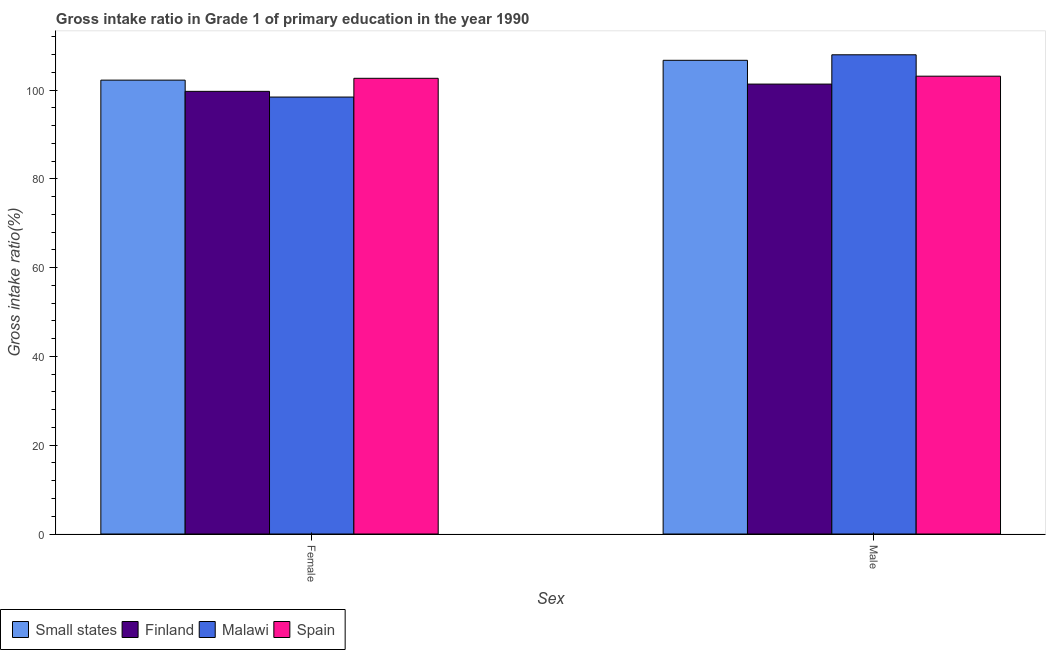What is the label of the 2nd group of bars from the left?
Give a very brief answer. Male. What is the gross intake ratio(male) in Small states?
Provide a succinct answer. 106.71. Across all countries, what is the maximum gross intake ratio(female)?
Provide a succinct answer. 102.65. Across all countries, what is the minimum gross intake ratio(male)?
Give a very brief answer. 101.35. In which country was the gross intake ratio(male) minimum?
Offer a very short reply. Finland. What is the total gross intake ratio(female) in the graph?
Provide a succinct answer. 403.04. What is the difference between the gross intake ratio(female) in Small states and that in Finland?
Your answer should be compact. 2.53. What is the difference between the gross intake ratio(male) in Small states and the gross intake ratio(female) in Spain?
Your answer should be very brief. 4.06. What is the average gross intake ratio(male) per country?
Offer a very short reply. 104.79. What is the difference between the gross intake ratio(male) and gross intake ratio(female) in Finland?
Keep it short and to the point. 1.64. What is the ratio of the gross intake ratio(male) in Small states to that in Malawi?
Give a very brief answer. 0.99. What does the 3rd bar from the left in Male represents?
Offer a terse response. Malawi. What does the 1st bar from the right in Male represents?
Offer a terse response. Spain. How many countries are there in the graph?
Keep it short and to the point. 4. Does the graph contain any zero values?
Ensure brevity in your answer.  No. Does the graph contain grids?
Provide a short and direct response. No. What is the title of the graph?
Ensure brevity in your answer.  Gross intake ratio in Grade 1 of primary education in the year 1990. What is the label or title of the X-axis?
Offer a very short reply. Sex. What is the label or title of the Y-axis?
Offer a terse response. Gross intake ratio(%). What is the Gross intake ratio(%) of Small states in Female?
Provide a short and direct response. 102.24. What is the Gross intake ratio(%) in Finland in Female?
Your response must be concise. 99.71. What is the Gross intake ratio(%) of Malawi in Female?
Ensure brevity in your answer.  98.43. What is the Gross intake ratio(%) of Spain in Female?
Your answer should be very brief. 102.65. What is the Gross intake ratio(%) of Small states in Male?
Give a very brief answer. 106.71. What is the Gross intake ratio(%) in Finland in Male?
Offer a terse response. 101.35. What is the Gross intake ratio(%) of Malawi in Male?
Offer a very short reply. 107.95. What is the Gross intake ratio(%) of Spain in Male?
Your answer should be compact. 103.13. Across all Sex, what is the maximum Gross intake ratio(%) of Small states?
Make the answer very short. 106.71. Across all Sex, what is the maximum Gross intake ratio(%) of Finland?
Offer a very short reply. 101.35. Across all Sex, what is the maximum Gross intake ratio(%) of Malawi?
Ensure brevity in your answer.  107.95. Across all Sex, what is the maximum Gross intake ratio(%) of Spain?
Provide a succinct answer. 103.13. Across all Sex, what is the minimum Gross intake ratio(%) of Small states?
Your answer should be very brief. 102.24. Across all Sex, what is the minimum Gross intake ratio(%) in Finland?
Give a very brief answer. 99.71. Across all Sex, what is the minimum Gross intake ratio(%) of Malawi?
Your answer should be compact. 98.43. Across all Sex, what is the minimum Gross intake ratio(%) of Spain?
Your response must be concise. 102.65. What is the total Gross intake ratio(%) in Small states in the graph?
Give a very brief answer. 208.95. What is the total Gross intake ratio(%) of Finland in the graph?
Keep it short and to the point. 201.07. What is the total Gross intake ratio(%) in Malawi in the graph?
Offer a terse response. 206.38. What is the total Gross intake ratio(%) in Spain in the graph?
Your response must be concise. 205.79. What is the difference between the Gross intake ratio(%) of Small states in Female and that in Male?
Make the answer very short. -4.47. What is the difference between the Gross intake ratio(%) of Finland in Female and that in Male?
Ensure brevity in your answer.  -1.64. What is the difference between the Gross intake ratio(%) of Malawi in Female and that in Male?
Your response must be concise. -9.52. What is the difference between the Gross intake ratio(%) in Spain in Female and that in Male?
Provide a succinct answer. -0.48. What is the difference between the Gross intake ratio(%) of Small states in Female and the Gross intake ratio(%) of Finland in Male?
Provide a short and direct response. 0.89. What is the difference between the Gross intake ratio(%) of Small states in Female and the Gross intake ratio(%) of Malawi in Male?
Your response must be concise. -5.71. What is the difference between the Gross intake ratio(%) of Small states in Female and the Gross intake ratio(%) of Spain in Male?
Keep it short and to the point. -0.89. What is the difference between the Gross intake ratio(%) of Finland in Female and the Gross intake ratio(%) of Malawi in Male?
Ensure brevity in your answer.  -8.24. What is the difference between the Gross intake ratio(%) in Finland in Female and the Gross intake ratio(%) in Spain in Male?
Your response must be concise. -3.42. What is the difference between the Gross intake ratio(%) of Malawi in Female and the Gross intake ratio(%) of Spain in Male?
Ensure brevity in your answer.  -4.7. What is the average Gross intake ratio(%) of Small states per Sex?
Offer a terse response. 104.47. What is the average Gross intake ratio(%) of Finland per Sex?
Provide a short and direct response. 100.53. What is the average Gross intake ratio(%) in Malawi per Sex?
Your answer should be very brief. 103.19. What is the average Gross intake ratio(%) of Spain per Sex?
Provide a succinct answer. 102.89. What is the difference between the Gross intake ratio(%) of Small states and Gross intake ratio(%) of Finland in Female?
Provide a short and direct response. 2.53. What is the difference between the Gross intake ratio(%) of Small states and Gross intake ratio(%) of Malawi in Female?
Your answer should be compact. 3.81. What is the difference between the Gross intake ratio(%) of Small states and Gross intake ratio(%) of Spain in Female?
Provide a succinct answer. -0.41. What is the difference between the Gross intake ratio(%) in Finland and Gross intake ratio(%) in Malawi in Female?
Your response must be concise. 1.28. What is the difference between the Gross intake ratio(%) in Finland and Gross intake ratio(%) in Spain in Female?
Your answer should be very brief. -2.94. What is the difference between the Gross intake ratio(%) of Malawi and Gross intake ratio(%) of Spain in Female?
Ensure brevity in your answer.  -4.22. What is the difference between the Gross intake ratio(%) in Small states and Gross intake ratio(%) in Finland in Male?
Your answer should be compact. 5.36. What is the difference between the Gross intake ratio(%) of Small states and Gross intake ratio(%) of Malawi in Male?
Make the answer very short. -1.24. What is the difference between the Gross intake ratio(%) of Small states and Gross intake ratio(%) of Spain in Male?
Provide a succinct answer. 3.57. What is the difference between the Gross intake ratio(%) of Finland and Gross intake ratio(%) of Malawi in Male?
Provide a short and direct response. -6.6. What is the difference between the Gross intake ratio(%) in Finland and Gross intake ratio(%) in Spain in Male?
Give a very brief answer. -1.78. What is the difference between the Gross intake ratio(%) in Malawi and Gross intake ratio(%) in Spain in Male?
Give a very brief answer. 4.82. What is the ratio of the Gross intake ratio(%) of Small states in Female to that in Male?
Offer a terse response. 0.96. What is the ratio of the Gross intake ratio(%) of Finland in Female to that in Male?
Your answer should be very brief. 0.98. What is the ratio of the Gross intake ratio(%) of Malawi in Female to that in Male?
Offer a terse response. 0.91. What is the difference between the highest and the second highest Gross intake ratio(%) of Small states?
Give a very brief answer. 4.47. What is the difference between the highest and the second highest Gross intake ratio(%) of Finland?
Your response must be concise. 1.64. What is the difference between the highest and the second highest Gross intake ratio(%) in Malawi?
Offer a terse response. 9.52. What is the difference between the highest and the second highest Gross intake ratio(%) in Spain?
Give a very brief answer. 0.48. What is the difference between the highest and the lowest Gross intake ratio(%) of Small states?
Ensure brevity in your answer.  4.47. What is the difference between the highest and the lowest Gross intake ratio(%) of Finland?
Offer a terse response. 1.64. What is the difference between the highest and the lowest Gross intake ratio(%) of Malawi?
Make the answer very short. 9.52. What is the difference between the highest and the lowest Gross intake ratio(%) of Spain?
Provide a short and direct response. 0.48. 